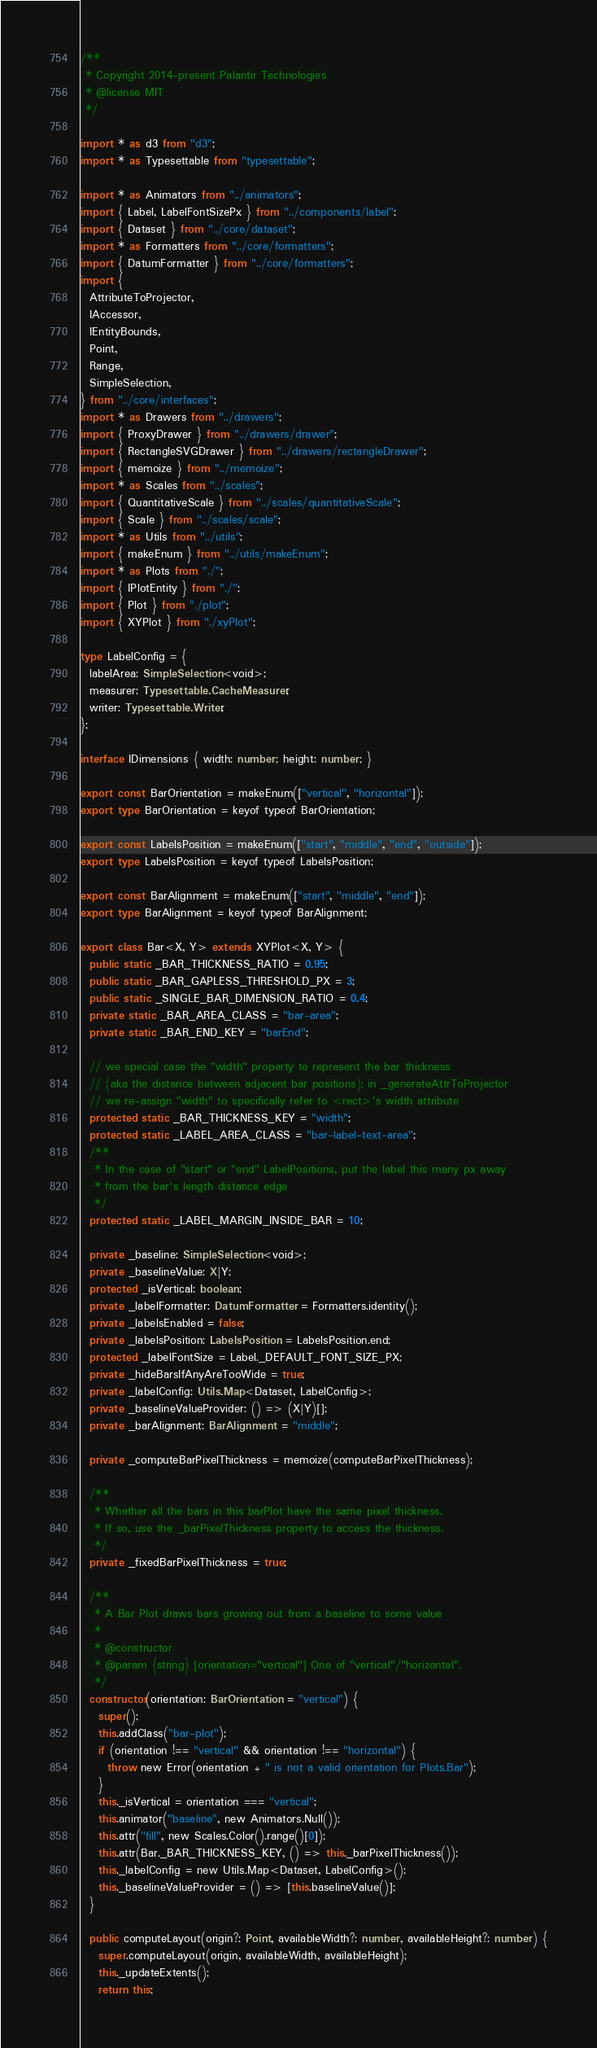Convert code to text. <code><loc_0><loc_0><loc_500><loc_500><_TypeScript_>/**
 * Copyright 2014-present Palantir Technologies
 * @license MIT
 */

import * as d3 from "d3";
import * as Typesettable from "typesettable";

import * as Animators from "../animators";
import { Label, LabelFontSizePx } from "../components/label";
import { Dataset } from "../core/dataset";
import * as Formatters from "../core/formatters";
import { DatumFormatter } from "../core/formatters";
import {
  AttributeToProjector,
  IAccessor,
  IEntityBounds,
  Point,
  Range,
  SimpleSelection,
} from "../core/interfaces";
import * as Drawers from "../drawers";
import { ProxyDrawer } from "../drawers/drawer";
import { RectangleSVGDrawer } from "../drawers/rectangleDrawer";
import { memoize } from "../memoize";
import * as Scales from "../scales";
import { QuantitativeScale } from "../scales/quantitativeScale";
import { Scale } from "../scales/scale";
import * as Utils from "../utils";
import { makeEnum } from "../utils/makeEnum";
import * as Plots from "./";
import { IPlotEntity } from "./";
import { Plot } from "./plot";
import { XYPlot } from "./xyPlot";

type LabelConfig = {
  labelArea: SimpleSelection<void>;
  measurer: Typesettable.CacheMeasurer;
  writer: Typesettable.Writer;
};

interface IDimensions { width: number; height: number; }

export const BarOrientation = makeEnum(["vertical", "horizontal"]);
export type BarOrientation = keyof typeof BarOrientation;

export const LabelsPosition = makeEnum(["start", "middle", "end", "outside"]);
export type LabelsPosition = keyof typeof LabelsPosition;

export const BarAlignment = makeEnum(["start", "middle", "end"]);
export type BarAlignment = keyof typeof BarAlignment;

export class Bar<X, Y> extends XYPlot<X, Y> {
  public static _BAR_THICKNESS_RATIO = 0.95;
  public static _BAR_GAPLESS_THRESHOLD_PX = 3;
  public static _SINGLE_BAR_DIMENSION_RATIO = 0.4;
  private static _BAR_AREA_CLASS = "bar-area";
  private static _BAR_END_KEY = "barEnd";

  // we special case the "width" property to represent the bar thickness
  // (aka the distance between adjacent bar positions); in _generateAttrToProjector
  // we re-assign "width" to specifically refer to <rect>'s width attribute
  protected static _BAR_THICKNESS_KEY = "width";
  protected static _LABEL_AREA_CLASS = "bar-label-text-area";
  /**
   * In the case of "start" or "end" LabelPositions, put the label this many px away
   * from the bar's length distance edge
   */
  protected static _LABEL_MARGIN_INSIDE_BAR = 10;

  private _baseline: SimpleSelection<void>;
  private _baselineValue: X|Y;
  protected _isVertical: boolean;
  private _labelFormatter: DatumFormatter = Formatters.identity();
  private _labelsEnabled = false;
  private _labelsPosition: LabelsPosition = LabelsPosition.end;
  protected _labelFontSize = Label._DEFAULT_FONT_SIZE_PX;
  private _hideBarsIfAnyAreTooWide = true;
  private _labelConfig: Utils.Map<Dataset, LabelConfig>;
  private _baselineValueProvider: () => (X|Y)[];
  private _barAlignment: BarAlignment = "middle";

  private _computeBarPixelThickness = memoize(computeBarPixelThickness);

  /**
   * Whether all the bars in this barPlot have the same pixel thickness.
   * If so, use the _barPixelThickness property to access the thickness.
   */
  private _fixedBarPixelThickness = true;

  /**
   * A Bar Plot draws bars growing out from a baseline to some value
   *
   * @constructor
   * @param {string} [orientation="vertical"] One of "vertical"/"horizontal".
   */
  constructor(orientation: BarOrientation = "vertical") {
    super();
    this.addClass("bar-plot");
    if (orientation !== "vertical" && orientation !== "horizontal") {
      throw new Error(orientation + " is not a valid orientation for Plots.Bar");
    }
    this._isVertical = orientation === "vertical";
    this.animator("baseline", new Animators.Null());
    this.attr("fill", new Scales.Color().range()[0]);
    this.attr(Bar._BAR_THICKNESS_KEY, () => this._barPixelThickness());
    this._labelConfig = new Utils.Map<Dataset, LabelConfig>();
    this._baselineValueProvider = () => [this.baselineValue()];
  }

  public computeLayout(origin?: Point, availableWidth?: number, availableHeight?: number) {
    super.computeLayout(origin, availableWidth, availableHeight);
    this._updateExtents();
    return this;</code> 